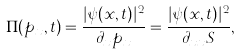<formula> <loc_0><loc_0><loc_500><loc_500>\Pi ( p _ { x } , t ) = \frac { | \psi ( x , t ) | ^ { 2 } } { \partial _ { x } p _ { x } } = \frac { | \psi ( x , t ) | ^ { 2 } } { \partial _ { x x } S } ,</formula> 